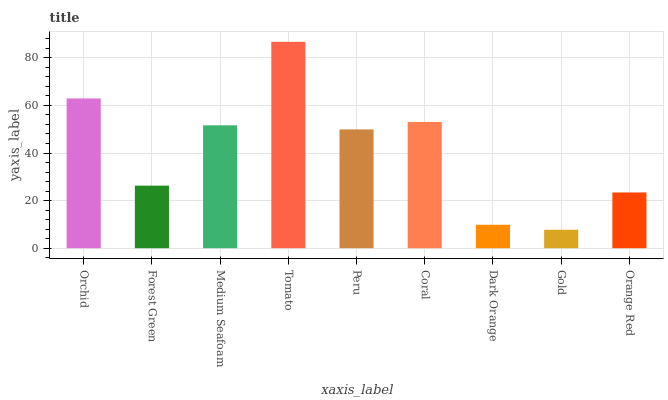Is Gold the minimum?
Answer yes or no. Yes. Is Tomato the maximum?
Answer yes or no. Yes. Is Forest Green the minimum?
Answer yes or no. No. Is Forest Green the maximum?
Answer yes or no. No. Is Orchid greater than Forest Green?
Answer yes or no. Yes. Is Forest Green less than Orchid?
Answer yes or no. Yes. Is Forest Green greater than Orchid?
Answer yes or no. No. Is Orchid less than Forest Green?
Answer yes or no. No. Is Peru the high median?
Answer yes or no. Yes. Is Peru the low median?
Answer yes or no. Yes. Is Tomato the high median?
Answer yes or no. No. Is Tomato the low median?
Answer yes or no. No. 